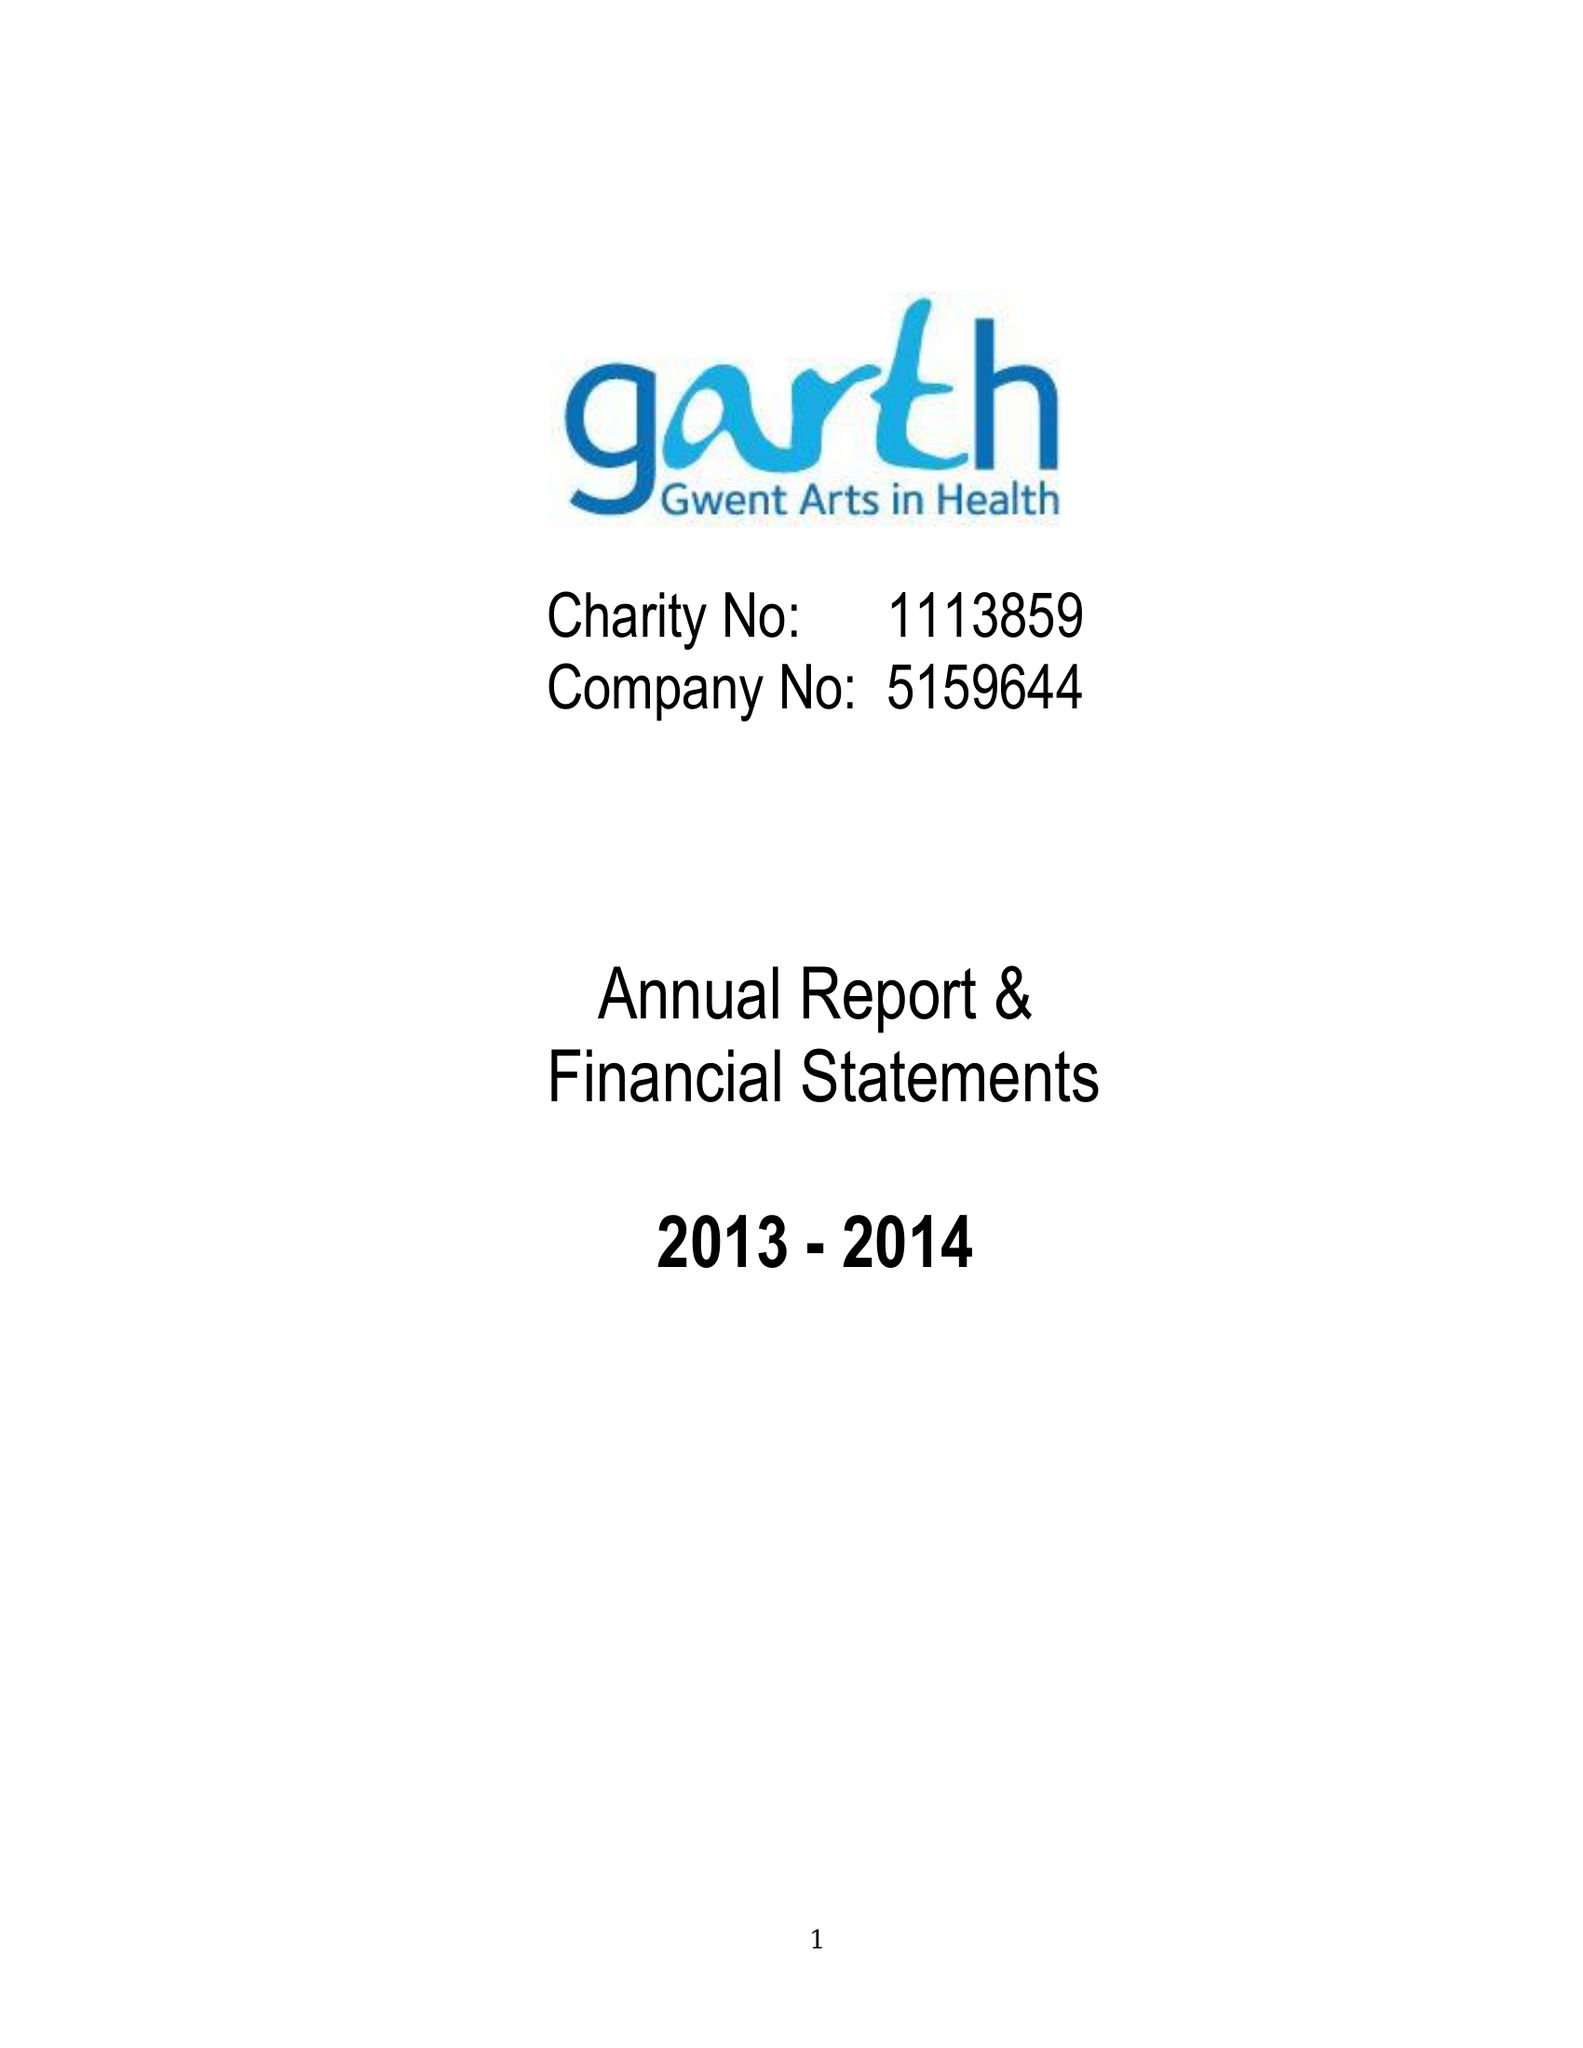What is the value for the report_date?
Answer the question using a single word or phrase. 2014-03-31 